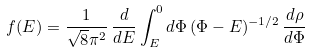Convert formula to latex. <formula><loc_0><loc_0><loc_500><loc_500>f ( E ) = \frac { 1 } { \sqrt { 8 } \pi ^ { 2 } } \, \frac { d } { d E } \int _ { E } ^ { 0 } d \Phi \, ( \Phi - E ) ^ { - 1 / 2 } \, \frac { d \rho } { d \Phi }</formula> 